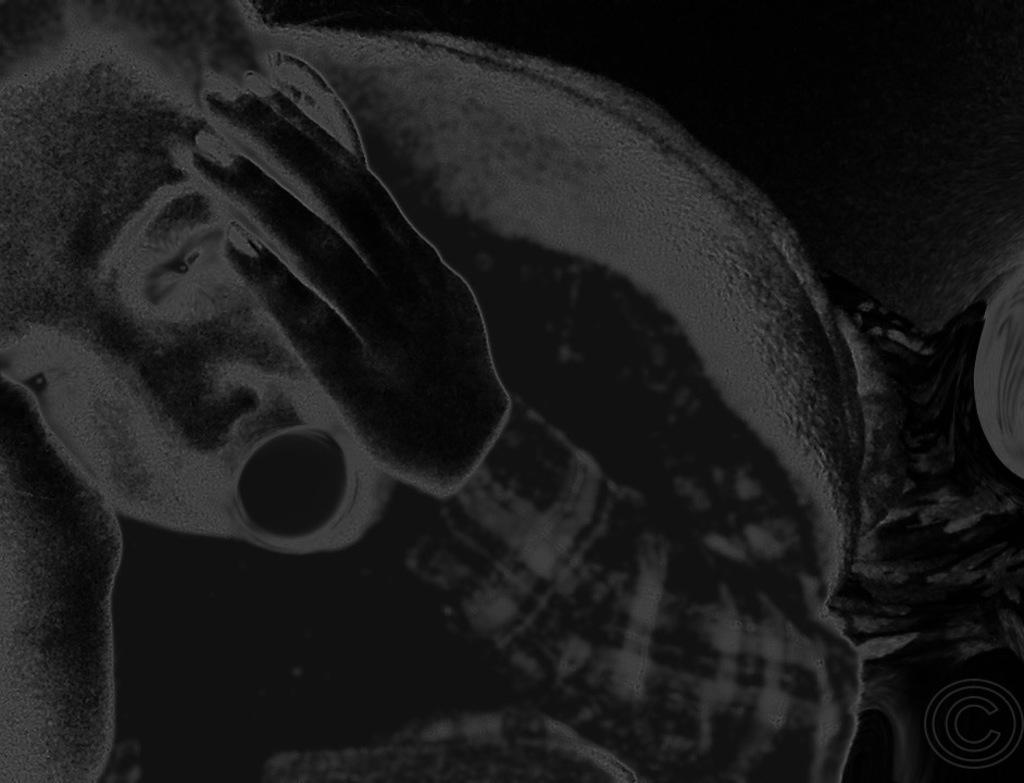What is the position of the person in the image? The person is lying on the left side of the image. Can you describe any additional features of the image? There is a watermark in the bottom right corner of the image. What type of shade is covering the person in the image? There is no shade covering the person in the image. 